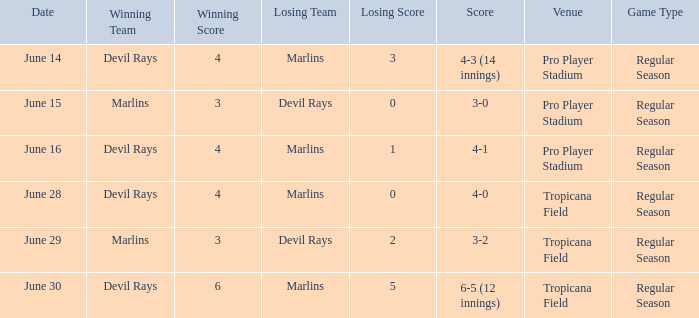On june 14, what was the winning score by the devil rays in pro player stadium? 4-3 (14 innings). 